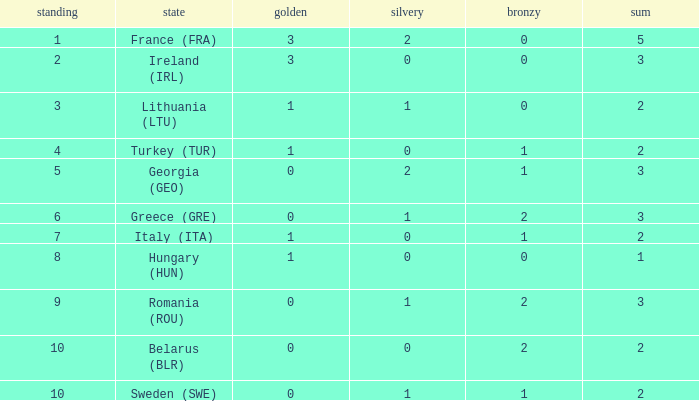I'm looking to parse the entire table for insights. Could you assist me with that? {'header': ['standing', 'state', 'golden', 'silvery', 'bronzy', 'sum'], 'rows': [['1', 'France (FRA)', '3', '2', '0', '5'], ['2', 'Ireland (IRL)', '3', '0', '0', '3'], ['3', 'Lithuania (LTU)', '1', '1', '0', '2'], ['4', 'Turkey (TUR)', '1', '0', '1', '2'], ['5', 'Georgia (GEO)', '0', '2', '1', '3'], ['6', 'Greece (GRE)', '0', '1', '2', '3'], ['7', 'Italy (ITA)', '1', '0', '1', '2'], ['8', 'Hungary (HUN)', '1', '0', '0', '1'], ['9', 'Romania (ROU)', '0', '1', '2', '3'], ['10', 'Belarus (BLR)', '0', '0', '2', '2'], ['10', 'Sweden (SWE)', '0', '1', '1', '2']]} What's the rank of Turkey (TUR) with a total more than 2? 0.0. 